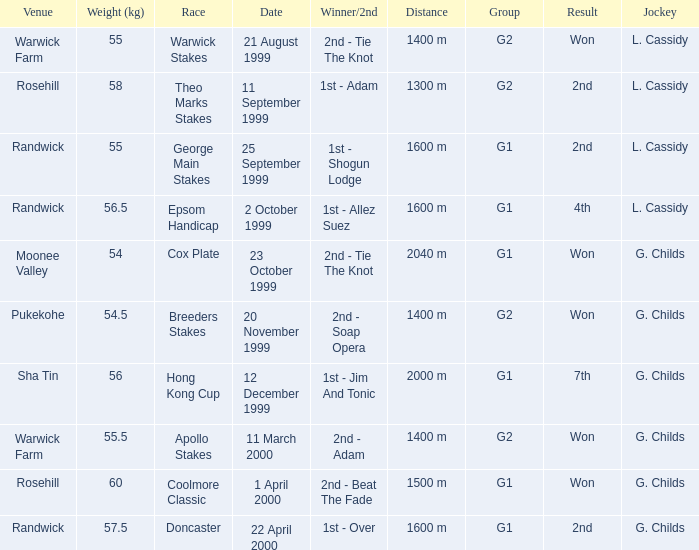How man teams had a total weight of 57.5? 1.0. 